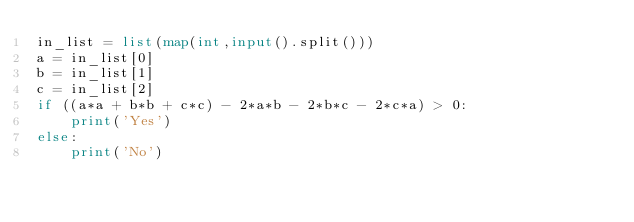<code> <loc_0><loc_0><loc_500><loc_500><_Python_>in_list = list(map(int,input().split()))
a = in_list[0]
b = in_list[1]
c = in_list[2]
if ((a*a + b*b + c*c) - 2*a*b - 2*b*c - 2*c*a) > 0:
    print('Yes')
else:
    print('No')</code> 